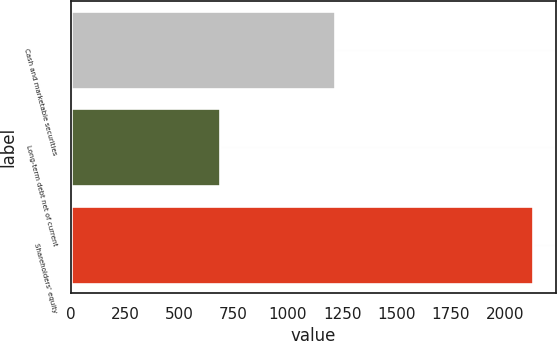Convert chart to OTSL. <chart><loc_0><loc_0><loc_500><loc_500><bar_chart><fcel>Cash and marketable securities<fcel>Long-term debt net of current<fcel>Shareholders' equity<nl><fcel>1217<fcel>686<fcel>2127<nl></chart> 